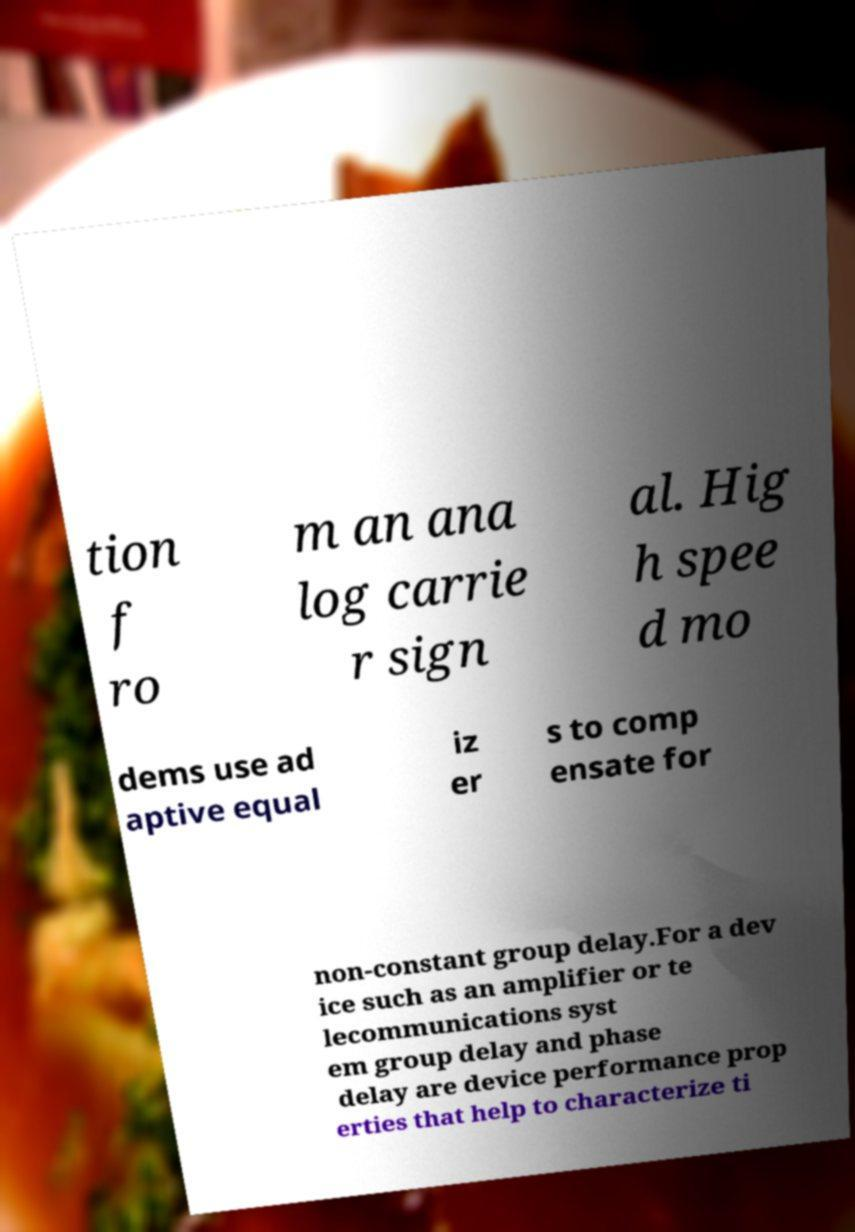For documentation purposes, I need the text within this image transcribed. Could you provide that? tion f ro m an ana log carrie r sign al. Hig h spee d mo dems use ad aptive equal iz er s to comp ensate for non-constant group delay.For a dev ice such as an amplifier or te lecommunications syst em group delay and phase delay are device performance prop erties that help to characterize ti 